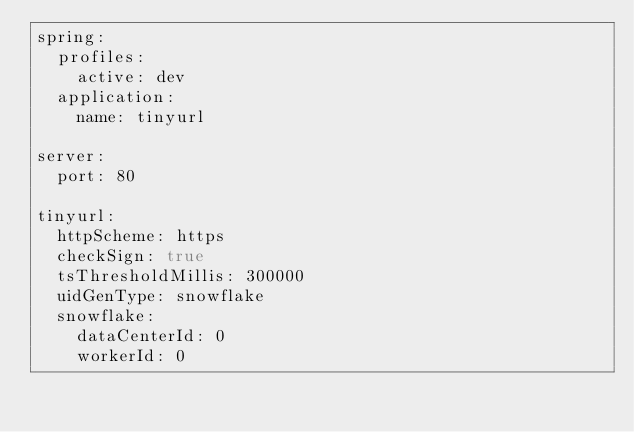<code> <loc_0><loc_0><loc_500><loc_500><_YAML_>spring:
  profiles:
    active: dev
  application:
    name: tinyurl

server:
  port: 80

tinyurl:
  httpScheme: https
  checkSign: true
  tsThresholdMillis: 300000
  uidGenType: snowflake
  snowflake:
    dataCenterId: 0
    workerId: 0</code> 